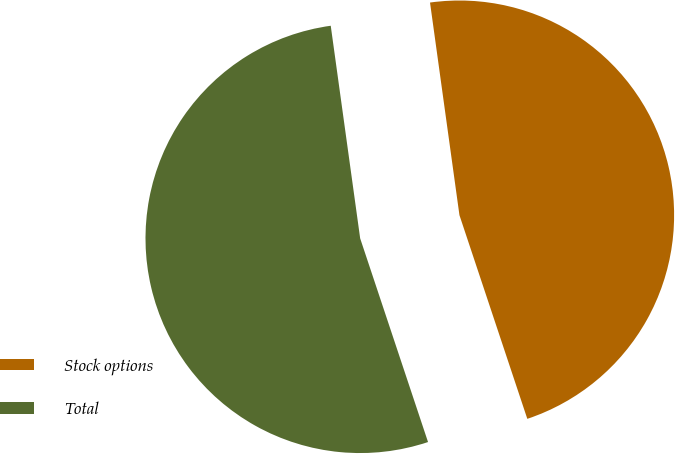Convert chart. <chart><loc_0><loc_0><loc_500><loc_500><pie_chart><fcel>Stock options<fcel>Total<nl><fcel>47.07%<fcel>52.93%<nl></chart> 